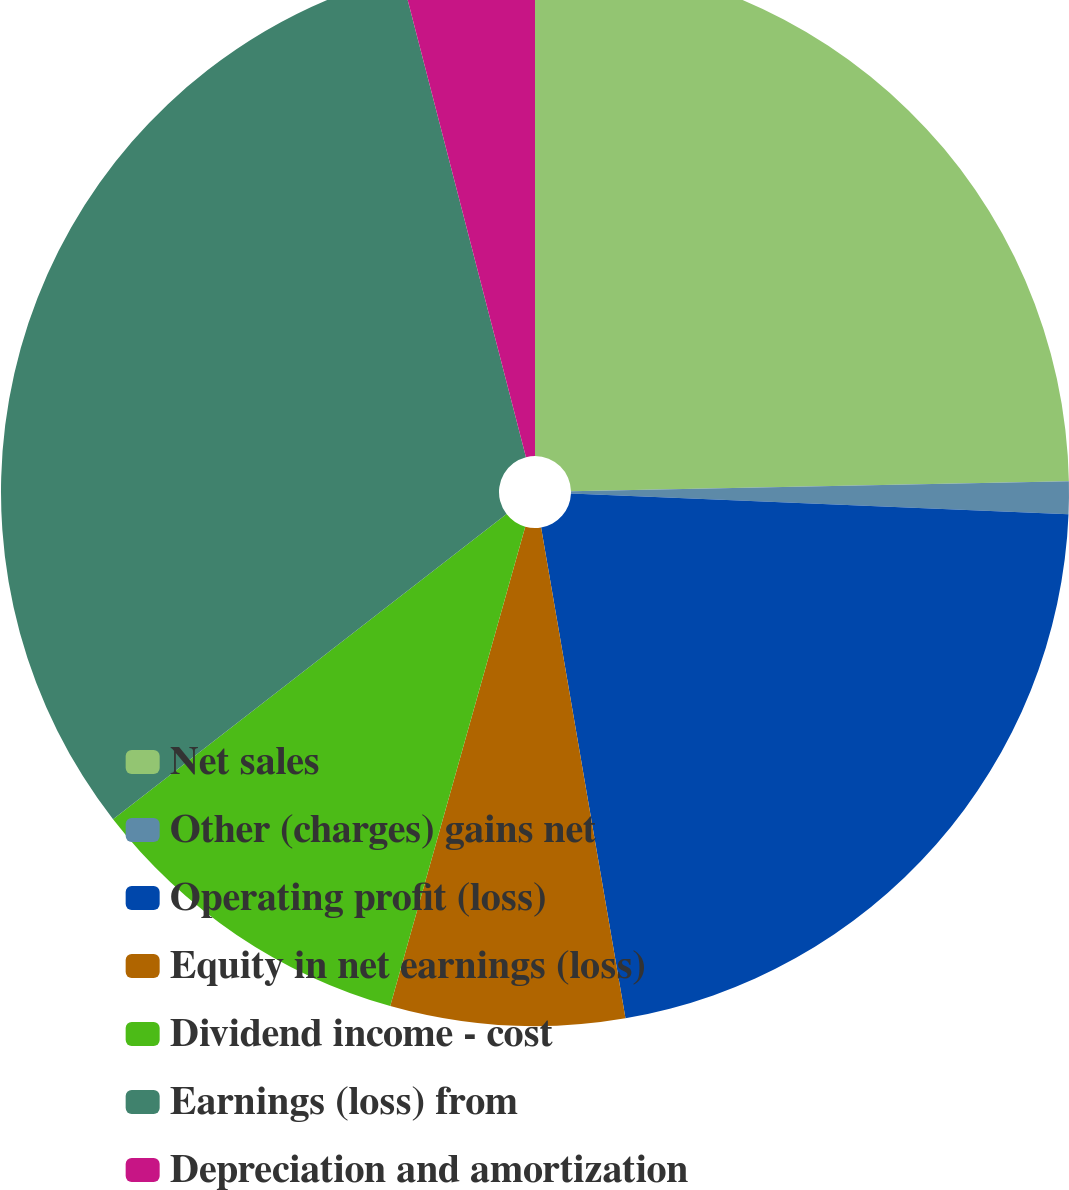<chart> <loc_0><loc_0><loc_500><loc_500><pie_chart><fcel>Net sales<fcel>Other (charges) gains net<fcel>Operating profit (loss)<fcel>Equity in net earnings (loss)<fcel>Dividend income - cost<fcel>Earnings (loss) from<fcel>Depreciation and amortization<nl><fcel>24.68%<fcel>0.98%<fcel>21.63%<fcel>7.08%<fcel>10.13%<fcel>31.47%<fcel>4.03%<nl></chart> 